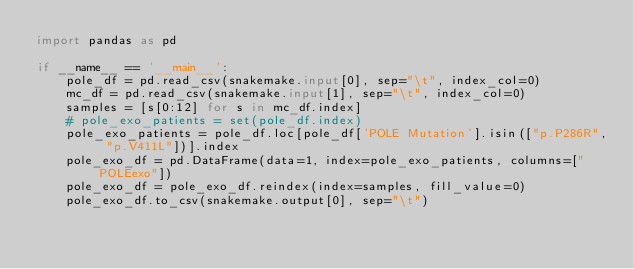Convert code to text. <code><loc_0><loc_0><loc_500><loc_500><_Python_>import pandas as pd

if __name__ == '__main__':
    pole_df = pd.read_csv(snakemake.input[0], sep="\t", index_col=0)
    mc_df = pd.read_csv(snakemake.input[1], sep="\t", index_col=0)
    samples = [s[0:12] for s in mc_df.index]
    # pole_exo_patients = set(pole_df.index)
    pole_exo_patients = pole_df.loc[pole_df['POLE Mutation'].isin(["p.P286R", "p.V411L"])].index
    pole_exo_df = pd.DataFrame(data=1, index=pole_exo_patients, columns=["POLEexo"])
    pole_exo_df = pole_exo_df.reindex(index=samples, fill_value=0)
    pole_exo_df.to_csv(snakemake.output[0], sep="\t")
</code> 